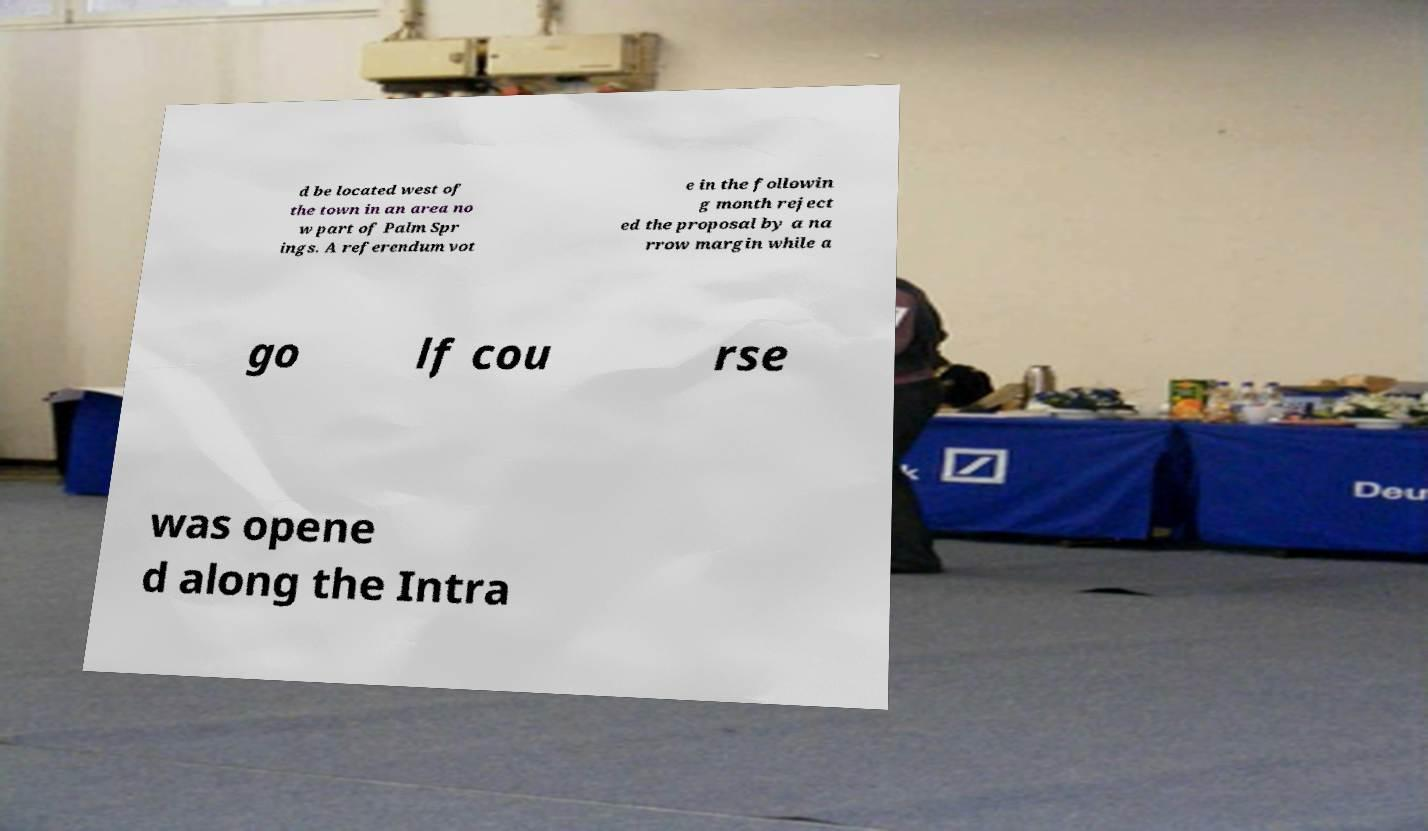I need the written content from this picture converted into text. Can you do that? d be located west of the town in an area no w part of Palm Spr ings. A referendum vot e in the followin g month reject ed the proposal by a na rrow margin while a go lf cou rse was opene d along the Intra 